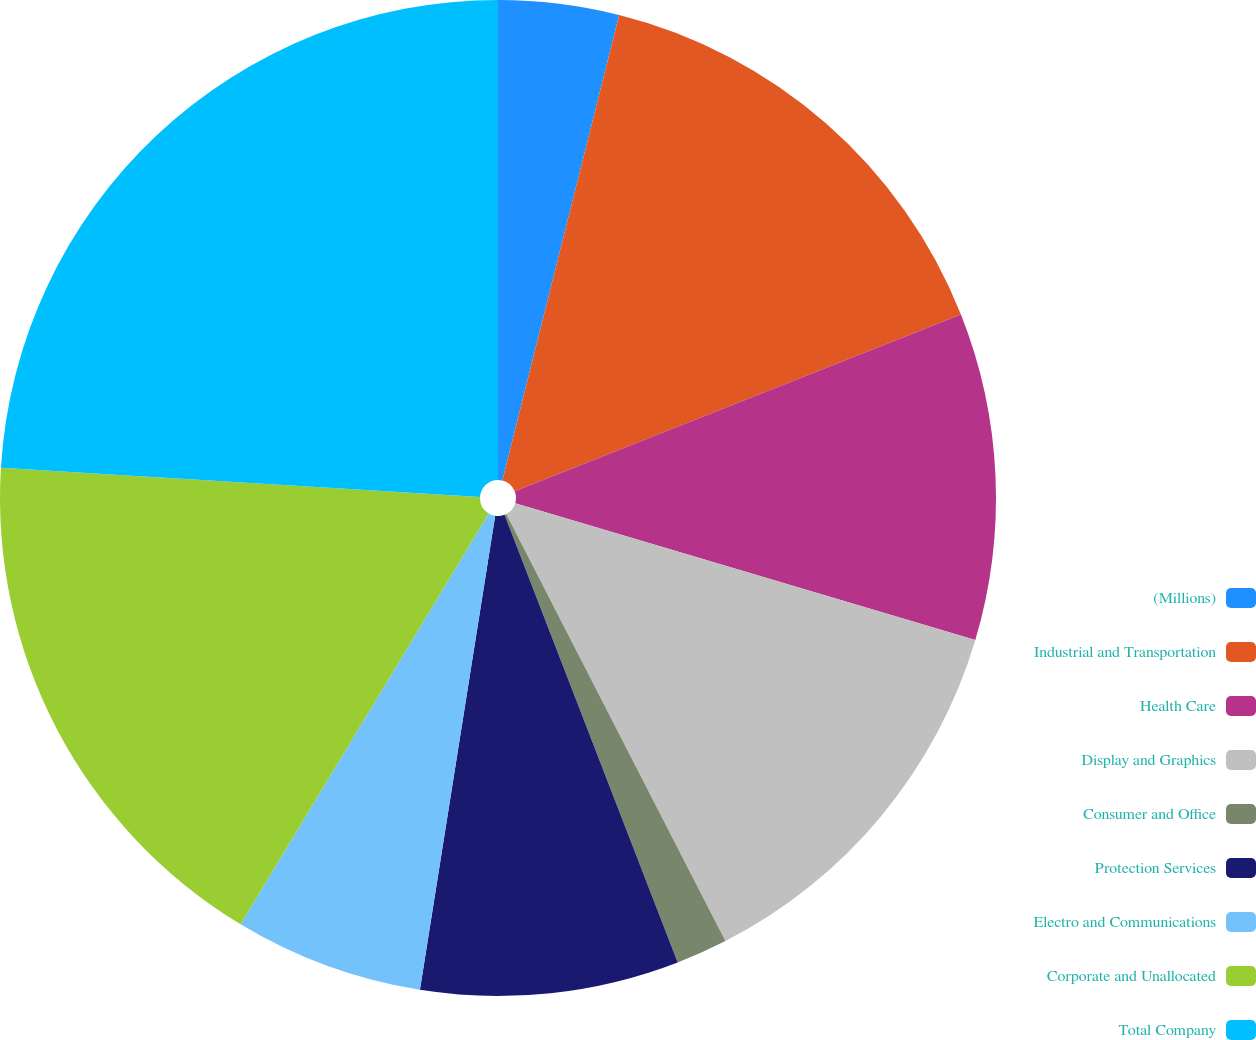<chart> <loc_0><loc_0><loc_500><loc_500><pie_chart><fcel>(Millions)<fcel>Industrial and Transportation<fcel>Health Care<fcel>Display and Graphics<fcel>Consumer and Office<fcel>Protection Services<fcel>Electro and Communications<fcel>Corporate and Unallocated<fcel>Total Company<nl><fcel>3.91%<fcel>15.08%<fcel>10.61%<fcel>12.85%<fcel>1.67%<fcel>8.38%<fcel>6.14%<fcel>17.32%<fcel>24.03%<nl></chart> 